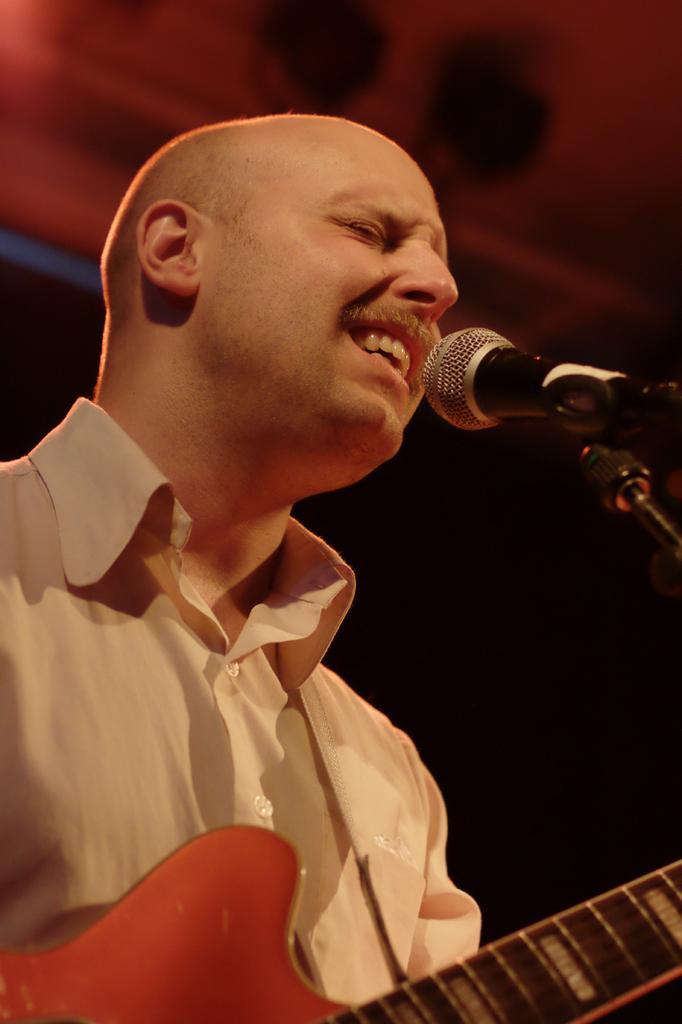Can you describe this image briefly? The person wearing white shirt is playing guitar and singing in front of a mic. 